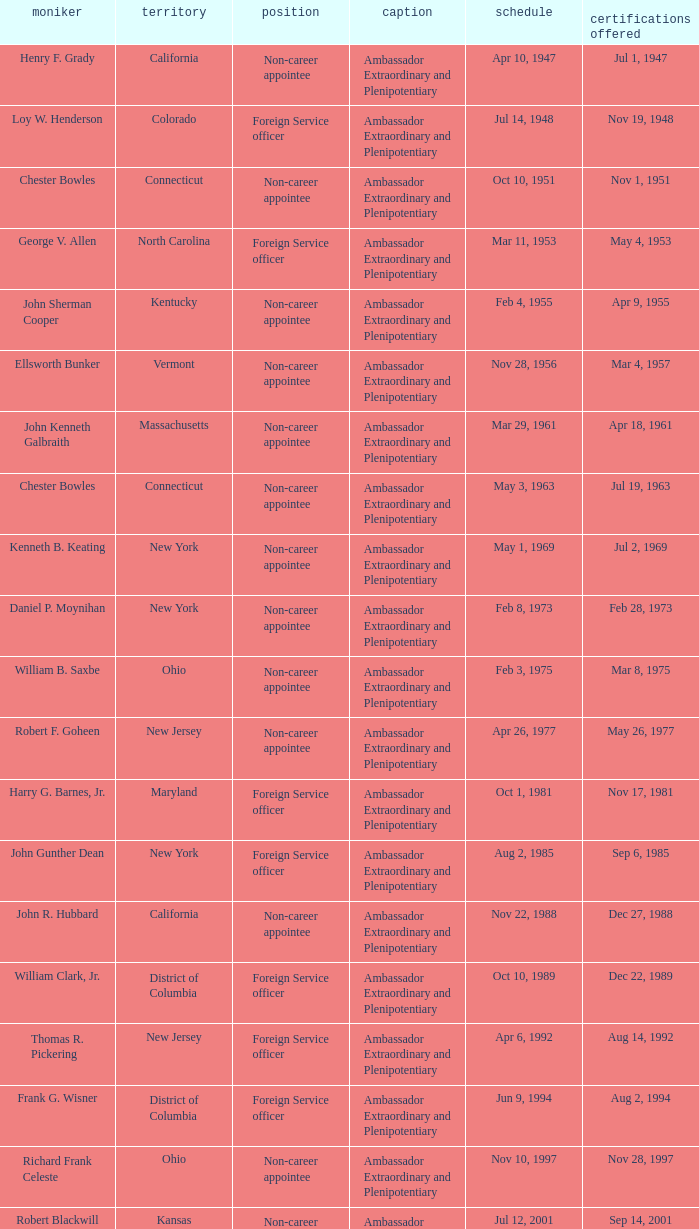What is the title for david campbell mulford? Ambassador Extraordinary and Plenipotentiary. 